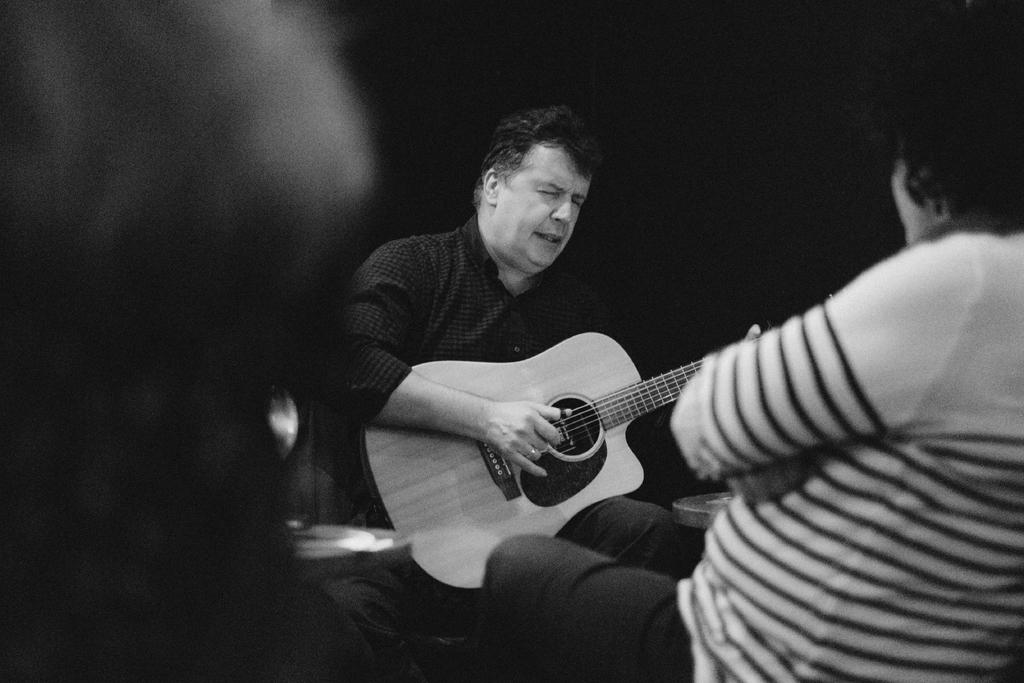What is the man in the image doing? The man is sitting, playing a guitar, and singing. Can you describe the people in front of the man? There are two persons in front of the man, and they are looking at him. What might the man be performing for the two persons? The man might be performing a song for the two persons, as he is playing a guitar and singing. What word is the turkey saying in the image? There is no turkey present in the image, and therefore no word can be attributed to it. 